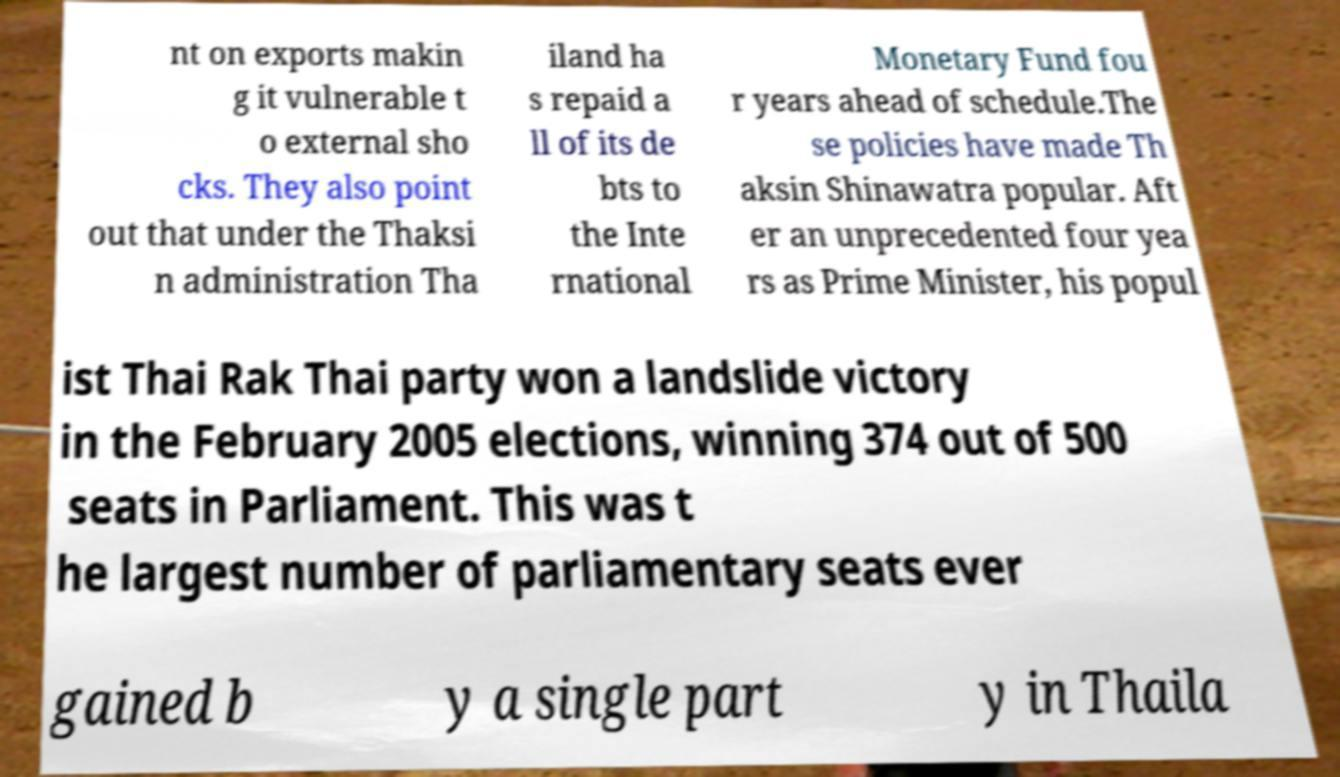What messages or text are displayed in this image? I need them in a readable, typed format. nt on exports makin g it vulnerable t o external sho cks. They also point out that under the Thaksi n administration Tha iland ha s repaid a ll of its de bts to the Inte rnational Monetary Fund fou r years ahead of schedule.The se policies have made Th aksin Shinawatra popular. Aft er an unprecedented four yea rs as Prime Minister, his popul ist Thai Rak Thai party won a landslide victory in the February 2005 elections, winning 374 out of 500 seats in Parliament. This was t he largest number of parliamentary seats ever gained b y a single part y in Thaila 